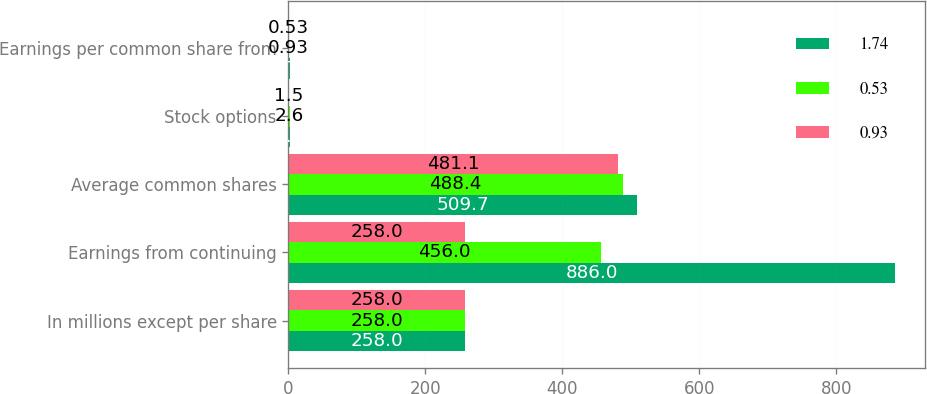Convert chart. <chart><loc_0><loc_0><loc_500><loc_500><stacked_bar_chart><ecel><fcel>In millions except per share<fcel>Earnings from continuing<fcel>Average common shares<fcel>Stock options<fcel>Earnings per common share from<nl><fcel>1.74<fcel>258<fcel>886<fcel>509.7<fcel>2.9<fcel>1.74<nl><fcel>0.53<fcel>258<fcel>456<fcel>488.4<fcel>2.6<fcel>0.93<nl><fcel>0.93<fcel>258<fcel>258<fcel>481.1<fcel>1.5<fcel>0.53<nl></chart> 